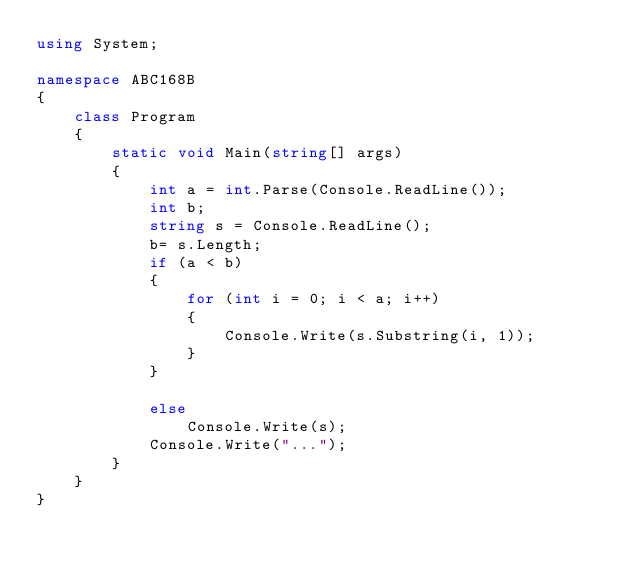<code> <loc_0><loc_0><loc_500><loc_500><_C#_>using System;

namespace ABC168B
{
    class Program
    {
        static void Main(string[] args)
        {
            int a = int.Parse(Console.ReadLine());
            int b;
            string s = Console.ReadLine();
            b= s.Length;
            if (a < b)
            {
                for (int i = 0; i < a; i++)
                {
                    Console.Write(s.Substring(i, 1));
                }
            }

            else
                Console.Write(s);
            Console.Write("...");
        }
    }
}
</code> 